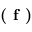Convert formula to latex. <formula><loc_0><loc_0><loc_500><loc_500>( f )</formula> 